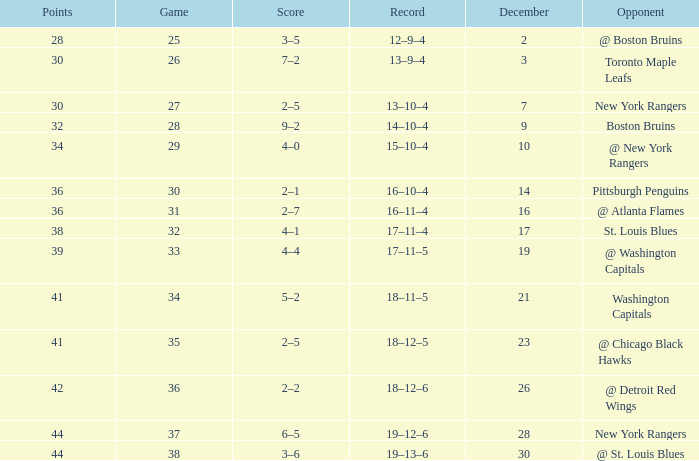Which Score has a Record of 18–11–5? 5–2. 